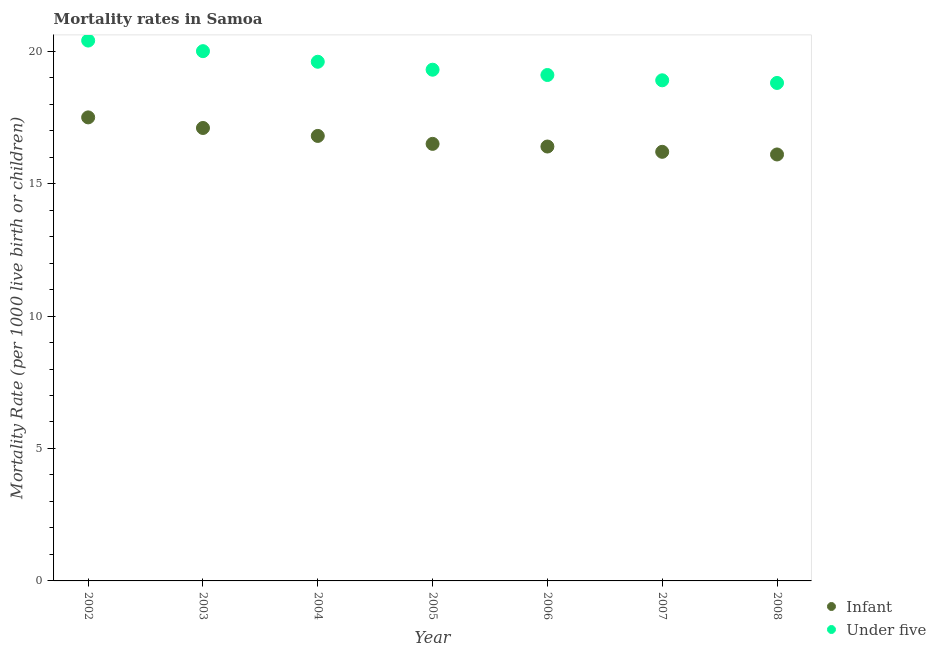How many different coloured dotlines are there?
Your answer should be compact. 2. What is the under-5 mortality rate in 2004?
Offer a terse response. 19.6. Across all years, what is the maximum infant mortality rate?
Ensure brevity in your answer.  17.5. Across all years, what is the minimum under-5 mortality rate?
Your response must be concise. 18.8. What is the total infant mortality rate in the graph?
Give a very brief answer. 116.6. What is the difference between the infant mortality rate in 2002 and that in 2003?
Provide a succinct answer. 0.4. What is the difference between the under-5 mortality rate in 2006 and the infant mortality rate in 2002?
Give a very brief answer. 1.6. What is the average infant mortality rate per year?
Offer a terse response. 16.66. In the year 2007, what is the difference between the under-5 mortality rate and infant mortality rate?
Your answer should be very brief. 2.7. What is the ratio of the infant mortality rate in 2003 to that in 2005?
Your response must be concise. 1.04. Is the under-5 mortality rate in 2004 less than that in 2005?
Offer a very short reply. No. What is the difference between the highest and the second highest under-5 mortality rate?
Make the answer very short. 0.4. What is the difference between the highest and the lowest under-5 mortality rate?
Your answer should be compact. 1.6. Is the sum of the under-5 mortality rate in 2003 and 2007 greater than the maximum infant mortality rate across all years?
Provide a succinct answer. Yes. Does the infant mortality rate monotonically increase over the years?
Provide a succinct answer. No. Is the under-5 mortality rate strictly less than the infant mortality rate over the years?
Make the answer very short. No. How many dotlines are there?
Ensure brevity in your answer.  2. Does the graph contain any zero values?
Offer a terse response. No. Does the graph contain grids?
Provide a short and direct response. No. Where does the legend appear in the graph?
Your response must be concise. Bottom right. How are the legend labels stacked?
Keep it short and to the point. Vertical. What is the title of the graph?
Your answer should be very brief. Mortality rates in Samoa. Does "All education staff compensation" appear as one of the legend labels in the graph?
Keep it short and to the point. No. What is the label or title of the X-axis?
Your response must be concise. Year. What is the label or title of the Y-axis?
Keep it short and to the point. Mortality Rate (per 1000 live birth or children). What is the Mortality Rate (per 1000 live birth or children) of Infant in 2002?
Provide a short and direct response. 17.5. What is the Mortality Rate (per 1000 live birth or children) in Under five in 2002?
Provide a short and direct response. 20.4. What is the Mortality Rate (per 1000 live birth or children) of Under five in 2003?
Offer a terse response. 20. What is the Mortality Rate (per 1000 live birth or children) in Infant in 2004?
Provide a short and direct response. 16.8. What is the Mortality Rate (per 1000 live birth or children) of Under five in 2004?
Give a very brief answer. 19.6. What is the Mortality Rate (per 1000 live birth or children) of Infant in 2005?
Give a very brief answer. 16.5. What is the Mortality Rate (per 1000 live birth or children) of Under five in 2005?
Offer a terse response. 19.3. What is the Mortality Rate (per 1000 live birth or children) of Under five in 2007?
Provide a succinct answer. 18.9. What is the Mortality Rate (per 1000 live birth or children) of Infant in 2008?
Your answer should be compact. 16.1. Across all years, what is the maximum Mortality Rate (per 1000 live birth or children) in Infant?
Provide a succinct answer. 17.5. Across all years, what is the maximum Mortality Rate (per 1000 live birth or children) in Under five?
Provide a short and direct response. 20.4. What is the total Mortality Rate (per 1000 live birth or children) in Infant in the graph?
Make the answer very short. 116.6. What is the total Mortality Rate (per 1000 live birth or children) in Under five in the graph?
Your answer should be very brief. 136.1. What is the difference between the Mortality Rate (per 1000 live birth or children) in Infant in 2002 and that in 2004?
Offer a very short reply. 0.7. What is the difference between the Mortality Rate (per 1000 live birth or children) in Under five in 2002 and that in 2005?
Keep it short and to the point. 1.1. What is the difference between the Mortality Rate (per 1000 live birth or children) in Infant in 2002 and that in 2006?
Provide a short and direct response. 1.1. What is the difference between the Mortality Rate (per 1000 live birth or children) of Infant in 2002 and that in 2007?
Make the answer very short. 1.3. What is the difference between the Mortality Rate (per 1000 live birth or children) in Under five in 2002 and that in 2008?
Make the answer very short. 1.6. What is the difference between the Mortality Rate (per 1000 live birth or children) of Infant in 2003 and that in 2004?
Make the answer very short. 0.3. What is the difference between the Mortality Rate (per 1000 live birth or children) of Infant in 2003 and that in 2005?
Offer a terse response. 0.6. What is the difference between the Mortality Rate (per 1000 live birth or children) of Under five in 2003 and that in 2005?
Offer a terse response. 0.7. What is the difference between the Mortality Rate (per 1000 live birth or children) of Infant in 2003 and that in 2008?
Your answer should be compact. 1. What is the difference between the Mortality Rate (per 1000 live birth or children) of Under five in 2004 and that in 2005?
Give a very brief answer. 0.3. What is the difference between the Mortality Rate (per 1000 live birth or children) in Infant in 2004 and that in 2006?
Offer a very short reply. 0.4. What is the difference between the Mortality Rate (per 1000 live birth or children) of Under five in 2004 and that in 2006?
Give a very brief answer. 0.5. What is the difference between the Mortality Rate (per 1000 live birth or children) of Under five in 2004 and that in 2007?
Ensure brevity in your answer.  0.7. What is the difference between the Mortality Rate (per 1000 live birth or children) in Infant in 2004 and that in 2008?
Provide a short and direct response. 0.7. What is the difference between the Mortality Rate (per 1000 live birth or children) of Under five in 2005 and that in 2006?
Your answer should be compact. 0.2. What is the difference between the Mortality Rate (per 1000 live birth or children) of Under five in 2005 and that in 2007?
Give a very brief answer. 0.4. What is the difference between the Mortality Rate (per 1000 live birth or children) of Under five in 2005 and that in 2008?
Provide a succinct answer. 0.5. What is the difference between the Mortality Rate (per 1000 live birth or children) of Infant in 2007 and that in 2008?
Your answer should be compact. 0.1. What is the difference between the Mortality Rate (per 1000 live birth or children) in Under five in 2007 and that in 2008?
Offer a very short reply. 0.1. What is the difference between the Mortality Rate (per 1000 live birth or children) in Infant in 2002 and the Mortality Rate (per 1000 live birth or children) in Under five in 2007?
Ensure brevity in your answer.  -1.4. What is the difference between the Mortality Rate (per 1000 live birth or children) in Infant in 2002 and the Mortality Rate (per 1000 live birth or children) in Under five in 2008?
Offer a very short reply. -1.3. What is the difference between the Mortality Rate (per 1000 live birth or children) of Infant in 2003 and the Mortality Rate (per 1000 live birth or children) of Under five in 2007?
Offer a very short reply. -1.8. What is the difference between the Mortality Rate (per 1000 live birth or children) of Infant in 2005 and the Mortality Rate (per 1000 live birth or children) of Under five in 2006?
Give a very brief answer. -2.6. What is the difference between the Mortality Rate (per 1000 live birth or children) of Infant in 2005 and the Mortality Rate (per 1000 live birth or children) of Under five in 2007?
Ensure brevity in your answer.  -2.4. What is the difference between the Mortality Rate (per 1000 live birth or children) of Infant in 2005 and the Mortality Rate (per 1000 live birth or children) of Under five in 2008?
Keep it short and to the point. -2.3. What is the difference between the Mortality Rate (per 1000 live birth or children) in Infant in 2007 and the Mortality Rate (per 1000 live birth or children) in Under five in 2008?
Your answer should be very brief. -2.6. What is the average Mortality Rate (per 1000 live birth or children) of Infant per year?
Your response must be concise. 16.66. What is the average Mortality Rate (per 1000 live birth or children) in Under five per year?
Keep it short and to the point. 19.44. In the year 2005, what is the difference between the Mortality Rate (per 1000 live birth or children) of Infant and Mortality Rate (per 1000 live birth or children) of Under five?
Provide a short and direct response. -2.8. In the year 2008, what is the difference between the Mortality Rate (per 1000 live birth or children) in Infant and Mortality Rate (per 1000 live birth or children) in Under five?
Offer a terse response. -2.7. What is the ratio of the Mortality Rate (per 1000 live birth or children) in Infant in 2002 to that in 2003?
Offer a terse response. 1.02. What is the ratio of the Mortality Rate (per 1000 live birth or children) of Under five in 2002 to that in 2003?
Offer a very short reply. 1.02. What is the ratio of the Mortality Rate (per 1000 live birth or children) of Infant in 2002 to that in 2004?
Make the answer very short. 1.04. What is the ratio of the Mortality Rate (per 1000 live birth or children) of Under five in 2002 to that in 2004?
Give a very brief answer. 1.04. What is the ratio of the Mortality Rate (per 1000 live birth or children) in Infant in 2002 to that in 2005?
Keep it short and to the point. 1.06. What is the ratio of the Mortality Rate (per 1000 live birth or children) of Under five in 2002 to that in 2005?
Offer a very short reply. 1.06. What is the ratio of the Mortality Rate (per 1000 live birth or children) of Infant in 2002 to that in 2006?
Make the answer very short. 1.07. What is the ratio of the Mortality Rate (per 1000 live birth or children) in Under five in 2002 to that in 2006?
Give a very brief answer. 1.07. What is the ratio of the Mortality Rate (per 1000 live birth or children) of Infant in 2002 to that in 2007?
Your answer should be very brief. 1.08. What is the ratio of the Mortality Rate (per 1000 live birth or children) of Under five in 2002 to that in 2007?
Your response must be concise. 1.08. What is the ratio of the Mortality Rate (per 1000 live birth or children) in Infant in 2002 to that in 2008?
Give a very brief answer. 1.09. What is the ratio of the Mortality Rate (per 1000 live birth or children) in Under five in 2002 to that in 2008?
Give a very brief answer. 1.09. What is the ratio of the Mortality Rate (per 1000 live birth or children) of Infant in 2003 to that in 2004?
Keep it short and to the point. 1.02. What is the ratio of the Mortality Rate (per 1000 live birth or children) of Under five in 2003 to that in 2004?
Offer a very short reply. 1.02. What is the ratio of the Mortality Rate (per 1000 live birth or children) in Infant in 2003 to that in 2005?
Provide a succinct answer. 1.04. What is the ratio of the Mortality Rate (per 1000 live birth or children) in Under five in 2003 to that in 2005?
Offer a terse response. 1.04. What is the ratio of the Mortality Rate (per 1000 live birth or children) in Infant in 2003 to that in 2006?
Keep it short and to the point. 1.04. What is the ratio of the Mortality Rate (per 1000 live birth or children) in Under five in 2003 to that in 2006?
Provide a succinct answer. 1.05. What is the ratio of the Mortality Rate (per 1000 live birth or children) of Infant in 2003 to that in 2007?
Offer a very short reply. 1.06. What is the ratio of the Mortality Rate (per 1000 live birth or children) of Under five in 2003 to that in 2007?
Provide a succinct answer. 1.06. What is the ratio of the Mortality Rate (per 1000 live birth or children) of Infant in 2003 to that in 2008?
Provide a succinct answer. 1.06. What is the ratio of the Mortality Rate (per 1000 live birth or children) in Under five in 2003 to that in 2008?
Your response must be concise. 1.06. What is the ratio of the Mortality Rate (per 1000 live birth or children) of Infant in 2004 to that in 2005?
Your answer should be very brief. 1.02. What is the ratio of the Mortality Rate (per 1000 live birth or children) of Under five in 2004 to that in 2005?
Ensure brevity in your answer.  1.02. What is the ratio of the Mortality Rate (per 1000 live birth or children) in Infant in 2004 to that in 2006?
Provide a succinct answer. 1.02. What is the ratio of the Mortality Rate (per 1000 live birth or children) of Under five in 2004 to that in 2006?
Ensure brevity in your answer.  1.03. What is the ratio of the Mortality Rate (per 1000 live birth or children) of Infant in 2004 to that in 2008?
Make the answer very short. 1.04. What is the ratio of the Mortality Rate (per 1000 live birth or children) of Under five in 2004 to that in 2008?
Your answer should be very brief. 1.04. What is the ratio of the Mortality Rate (per 1000 live birth or children) in Under five in 2005 to that in 2006?
Keep it short and to the point. 1.01. What is the ratio of the Mortality Rate (per 1000 live birth or children) of Infant in 2005 to that in 2007?
Offer a terse response. 1.02. What is the ratio of the Mortality Rate (per 1000 live birth or children) in Under five in 2005 to that in 2007?
Keep it short and to the point. 1.02. What is the ratio of the Mortality Rate (per 1000 live birth or children) in Infant in 2005 to that in 2008?
Keep it short and to the point. 1.02. What is the ratio of the Mortality Rate (per 1000 live birth or children) of Under five in 2005 to that in 2008?
Provide a short and direct response. 1.03. What is the ratio of the Mortality Rate (per 1000 live birth or children) of Infant in 2006 to that in 2007?
Ensure brevity in your answer.  1.01. What is the ratio of the Mortality Rate (per 1000 live birth or children) in Under five in 2006 to that in 2007?
Provide a succinct answer. 1.01. What is the ratio of the Mortality Rate (per 1000 live birth or children) in Infant in 2006 to that in 2008?
Provide a short and direct response. 1.02. What is the ratio of the Mortality Rate (per 1000 live birth or children) in Under five in 2007 to that in 2008?
Provide a succinct answer. 1.01. 